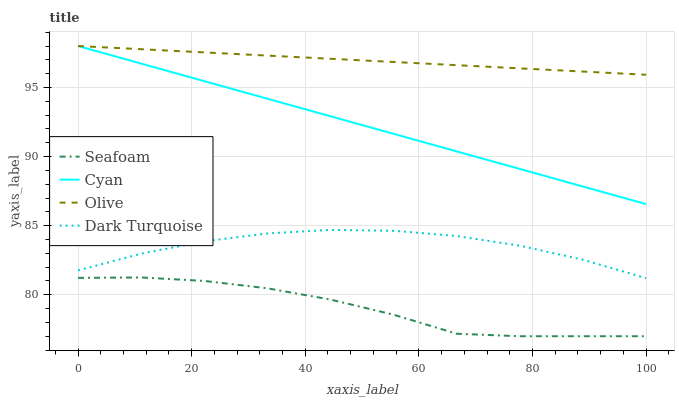Does Cyan have the minimum area under the curve?
Answer yes or no. No. Does Cyan have the maximum area under the curve?
Answer yes or no. No. Is Seafoam the smoothest?
Answer yes or no. No. Is Cyan the roughest?
Answer yes or no. No. Does Cyan have the lowest value?
Answer yes or no. No. Does Seafoam have the highest value?
Answer yes or no. No. Is Seafoam less than Dark Turquoise?
Answer yes or no. Yes. Is Cyan greater than Seafoam?
Answer yes or no. Yes. Does Seafoam intersect Dark Turquoise?
Answer yes or no. No. 